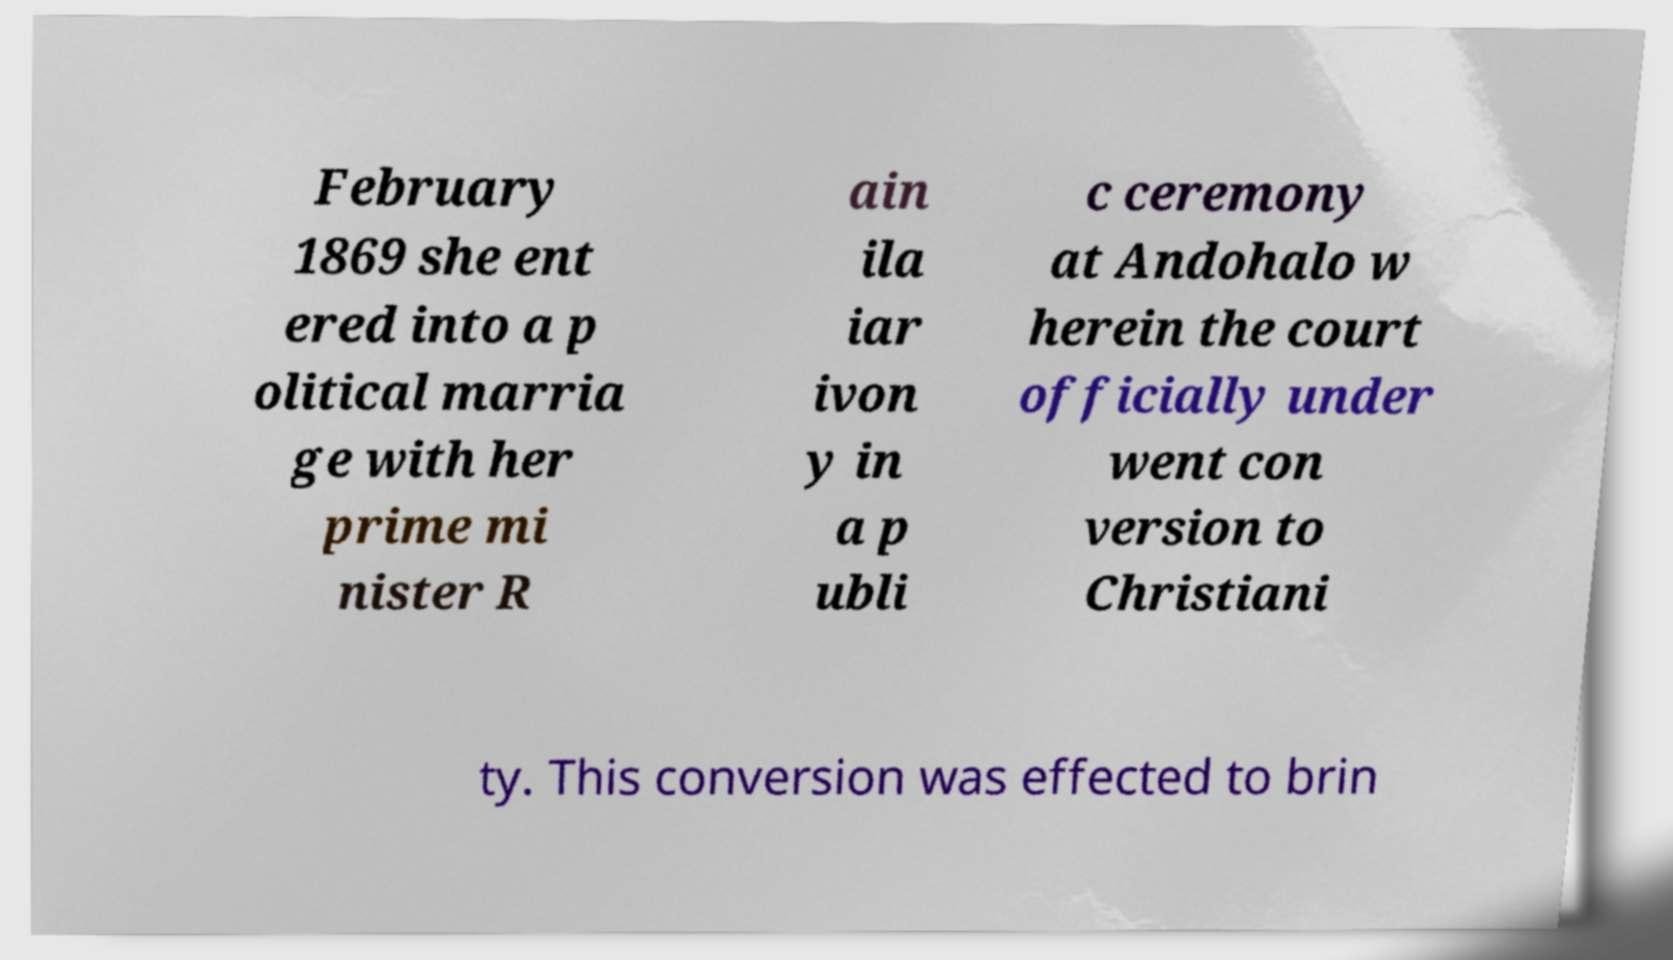Please identify and transcribe the text found in this image. February 1869 she ent ered into a p olitical marria ge with her prime mi nister R ain ila iar ivon y in a p ubli c ceremony at Andohalo w herein the court officially under went con version to Christiani ty. This conversion was effected to brin 